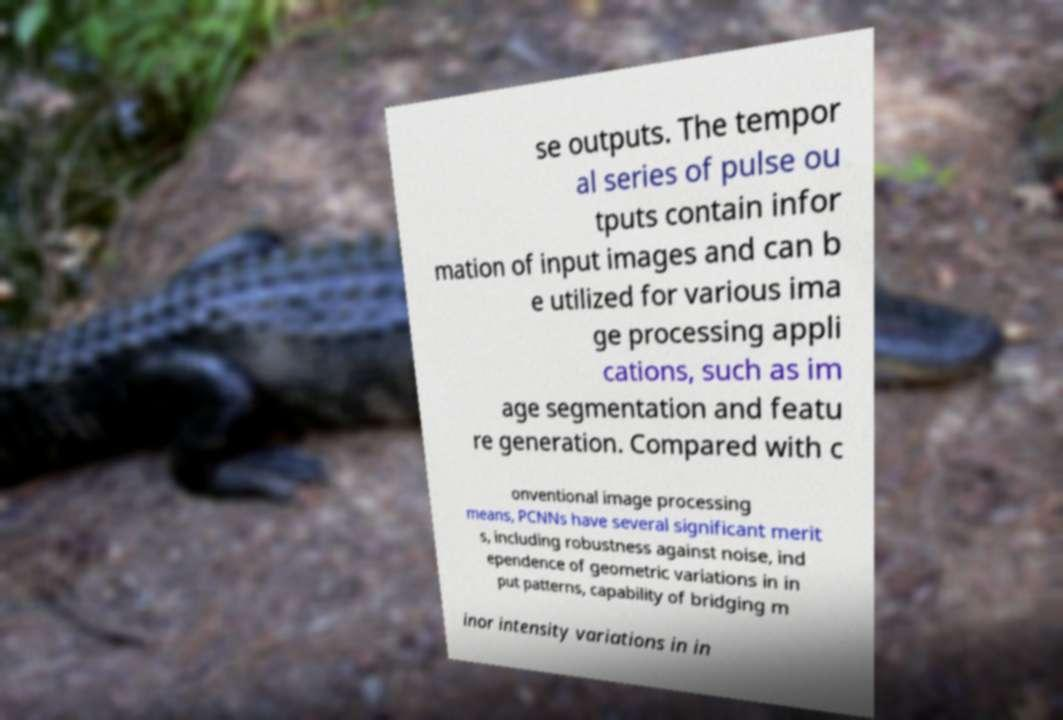For documentation purposes, I need the text within this image transcribed. Could you provide that? se outputs. The tempor al series of pulse ou tputs contain infor mation of input images and can b e utilized for various ima ge processing appli cations, such as im age segmentation and featu re generation. Compared with c onventional image processing means, PCNNs have several significant merit s, including robustness against noise, ind ependence of geometric variations in in put patterns, capability of bridging m inor intensity variations in in 